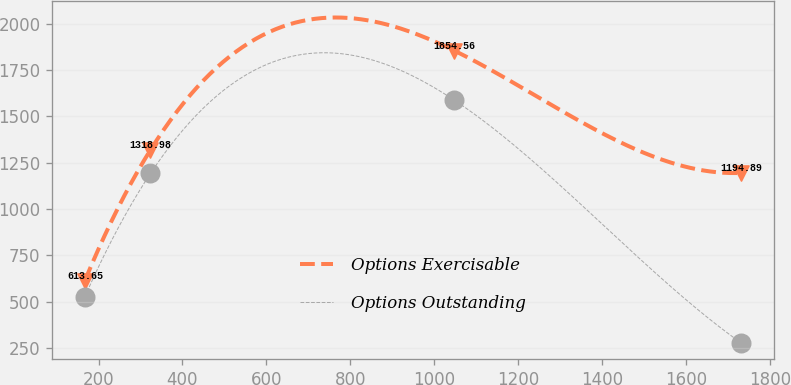Convert chart. <chart><loc_0><loc_0><loc_500><loc_500><line_chart><ecel><fcel>Options Exercisable<fcel>Options Outstanding<nl><fcel>167.41<fcel>613.65<fcel>527.19<nl><fcel>323.74<fcel>1318.98<fcel>1191.95<nl><fcel>1048.12<fcel>1854.56<fcel>1587.37<nl><fcel>1730.75<fcel>1194.89<fcel>278.7<nl></chart> 